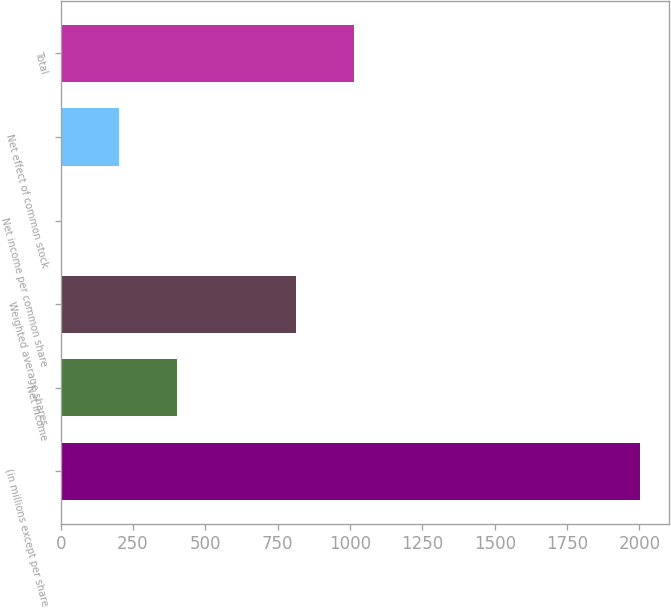<chart> <loc_0><loc_0><loc_500><loc_500><bar_chart><fcel>(in millions except per share<fcel>Net income<fcel>Weighted average shares<fcel>Net income per common share<fcel>Net effect of common stock<fcel>Total<nl><fcel>2002<fcel>400.76<fcel>814.2<fcel>0.46<fcel>200.61<fcel>1014.35<nl></chart> 